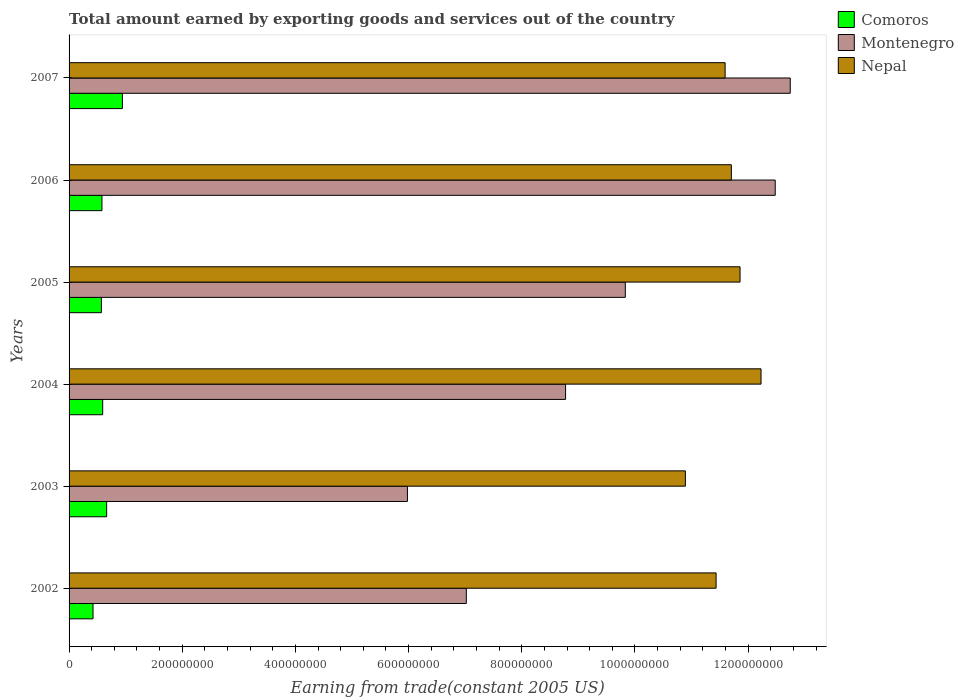How many different coloured bars are there?
Provide a short and direct response. 3. How many groups of bars are there?
Ensure brevity in your answer.  6. Are the number of bars on each tick of the Y-axis equal?
Provide a succinct answer. Yes. How many bars are there on the 6th tick from the top?
Your response must be concise. 3. What is the label of the 4th group of bars from the top?
Ensure brevity in your answer.  2004. What is the total amount earned by exporting goods and services in Comoros in 2007?
Keep it short and to the point. 9.43e+07. Across all years, what is the maximum total amount earned by exporting goods and services in Montenegro?
Keep it short and to the point. 1.27e+09. Across all years, what is the minimum total amount earned by exporting goods and services in Nepal?
Your answer should be very brief. 1.09e+09. In which year was the total amount earned by exporting goods and services in Montenegro maximum?
Your answer should be compact. 2007. In which year was the total amount earned by exporting goods and services in Montenegro minimum?
Provide a succinct answer. 2003. What is the total total amount earned by exporting goods and services in Nepal in the graph?
Your response must be concise. 6.97e+09. What is the difference between the total amount earned by exporting goods and services in Montenegro in 2002 and that in 2005?
Give a very brief answer. -2.81e+08. What is the difference between the total amount earned by exporting goods and services in Nepal in 2004 and the total amount earned by exporting goods and services in Comoros in 2006?
Make the answer very short. 1.16e+09. What is the average total amount earned by exporting goods and services in Comoros per year?
Provide a short and direct response. 6.29e+07. In the year 2002, what is the difference between the total amount earned by exporting goods and services in Montenegro and total amount earned by exporting goods and services in Nepal?
Your answer should be compact. -4.41e+08. What is the ratio of the total amount earned by exporting goods and services in Comoros in 2002 to that in 2003?
Your answer should be compact. 0.64. Is the total amount earned by exporting goods and services in Comoros in 2006 less than that in 2007?
Offer a terse response. Yes. What is the difference between the highest and the second highest total amount earned by exporting goods and services in Nepal?
Your response must be concise. 3.71e+07. What is the difference between the highest and the lowest total amount earned by exporting goods and services in Comoros?
Make the answer very short. 5.20e+07. What does the 2nd bar from the top in 2006 represents?
Offer a very short reply. Montenegro. What does the 3rd bar from the bottom in 2002 represents?
Make the answer very short. Nepal. What is the title of the graph?
Provide a short and direct response. Total amount earned by exporting goods and services out of the country. What is the label or title of the X-axis?
Your response must be concise. Earning from trade(constant 2005 US). What is the label or title of the Y-axis?
Provide a short and direct response. Years. What is the Earning from trade(constant 2005 US) of Comoros in 2002?
Provide a succinct answer. 4.23e+07. What is the Earning from trade(constant 2005 US) of Montenegro in 2002?
Your answer should be compact. 7.02e+08. What is the Earning from trade(constant 2005 US) of Nepal in 2002?
Your answer should be very brief. 1.14e+09. What is the Earning from trade(constant 2005 US) in Comoros in 2003?
Provide a succinct answer. 6.64e+07. What is the Earning from trade(constant 2005 US) in Montenegro in 2003?
Give a very brief answer. 5.98e+08. What is the Earning from trade(constant 2005 US) of Nepal in 2003?
Provide a succinct answer. 1.09e+09. What is the Earning from trade(constant 2005 US) of Comoros in 2004?
Keep it short and to the point. 5.94e+07. What is the Earning from trade(constant 2005 US) of Montenegro in 2004?
Your answer should be compact. 8.77e+08. What is the Earning from trade(constant 2005 US) in Nepal in 2004?
Provide a short and direct response. 1.22e+09. What is the Earning from trade(constant 2005 US) in Comoros in 2005?
Your answer should be compact. 5.71e+07. What is the Earning from trade(constant 2005 US) in Montenegro in 2005?
Provide a succinct answer. 9.83e+08. What is the Earning from trade(constant 2005 US) in Nepal in 2005?
Your answer should be very brief. 1.19e+09. What is the Earning from trade(constant 2005 US) of Comoros in 2006?
Offer a very short reply. 5.81e+07. What is the Earning from trade(constant 2005 US) of Montenegro in 2006?
Offer a terse response. 1.25e+09. What is the Earning from trade(constant 2005 US) of Nepal in 2006?
Make the answer very short. 1.17e+09. What is the Earning from trade(constant 2005 US) of Comoros in 2007?
Ensure brevity in your answer.  9.43e+07. What is the Earning from trade(constant 2005 US) of Montenegro in 2007?
Offer a terse response. 1.27e+09. What is the Earning from trade(constant 2005 US) of Nepal in 2007?
Offer a terse response. 1.16e+09. Across all years, what is the maximum Earning from trade(constant 2005 US) in Comoros?
Make the answer very short. 9.43e+07. Across all years, what is the maximum Earning from trade(constant 2005 US) of Montenegro?
Provide a succinct answer. 1.27e+09. Across all years, what is the maximum Earning from trade(constant 2005 US) in Nepal?
Ensure brevity in your answer.  1.22e+09. Across all years, what is the minimum Earning from trade(constant 2005 US) of Comoros?
Your response must be concise. 4.23e+07. Across all years, what is the minimum Earning from trade(constant 2005 US) of Montenegro?
Your answer should be compact. 5.98e+08. Across all years, what is the minimum Earning from trade(constant 2005 US) of Nepal?
Your answer should be very brief. 1.09e+09. What is the total Earning from trade(constant 2005 US) in Comoros in the graph?
Keep it short and to the point. 3.78e+08. What is the total Earning from trade(constant 2005 US) of Montenegro in the graph?
Offer a very short reply. 5.68e+09. What is the total Earning from trade(constant 2005 US) in Nepal in the graph?
Make the answer very short. 6.97e+09. What is the difference between the Earning from trade(constant 2005 US) in Comoros in 2002 and that in 2003?
Ensure brevity in your answer.  -2.41e+07. What is the difference between the Earning from trade(constant 2005 US) in Montenegro in 2002 and that in 2003?
Provide a short and direct response. 1.04e+08. What is the difference between the Earning from trade(constant 2005 US) of Nepal in 2002 and that in 2003?
Make the answer very short. 5.43e+07. What is the difference between the Earning from trade(constant 2005 US) of Comoros in 2002 and that in 2004?
Make the answer very short. -1.71e+07. What is the difference between the Earning from trade(constant 2005 US) of Montenegro in 2002 and that in 2004?
Your answer should be compact. -1.75e+08. What is the difference between the Earning from trade(constant 2005 US) of Nepal in 2002 and that in 2004?
Provide a succinct answer. -7.94e+07. What is the difference between the Earning from trade(constant 2005 US) in Comoros in 2002 and that in 2005?
Give a very brief answer. -1.48e+07. What is the difference between the Earning from trade(constant 2005 US) of Montenegro in 2002 and that in 2005?
Your answer should be compact. -2.81e+08. What is the difference between the Earning from trade(constant 2005 US) in Nepal in 2002 and that in 2005?
Provide a succinct answer. -4.23e+07. What is the difference between the Earning from trade(constant 2005 US) of Comoros in 2002 and that in 2006?
Your answer should be very brief. -1.58e+07. What is the difference between the Earning from trade(constant 2005 US) in Montenegro in 2002 and that in 2006?
Give a very brief answer. -5.46e+08. What is the difference between the Earning from trade(constant 2005 US) of Nepal in 2002 and that in 2006?
Provide a succinct answer. -2.70e+07. What is the difference between the Earning from trade(constant 2005 US) of Comoros in 2002 and that in 2007?
Ensure brevity in your answer.  -5.20e+07. What is the difference between the Earning from trade(constant 2005 US) in Montenegro in 2002 and that in 2007?
Your answer should be compact. -5.72e+08. What is the difference between the Earning from trade(constant 2005 US) in Nepal in 2002 and that in 2007?
Your answer should be compact. -1.59e+07. What is the difference between the Earning from trade(constant 2005 US) in Comoros in 2003 and that in 2004?
Your answer should be compact. 6.98e+06. What is the difference between the Earning from trade(constant 2005 US) in Montenegro in 2003 and that in 2004?
Keep it short and to the point. -2.79e+08. What is the difference between the Earning from trade(constant 2005 US) in Nepal in 2003 and that in 2004?
Offer a terse response. -1.34e+08. What is the difference between the Earning from trade(constant 2005 US) in Comoros in 2003 and that in 2005?
Keep it short and to the point. 9.30e+06. What is the difference between the Earning from trade(constant 2005 US) in Montenegro in 2003 and that in 2005?
Provide a short and direct response. -3.85e+08. What is the difference between the Earning from trade(constant 2005 US) in Nepal in 2003 and that in 2005?
Your response must be concise. -9.66e+07. What is the difference between the Earning from trade(constant 2005 US) of Comoros in 2003 and that in 2006?
Give a very brief answer. 8.30e+06. What is the difference between the Earning from trade(constant 2005 US) of Montenegro in 2003 and that in 2006?
Your response must be concise. -6.50e+08. What is the difference between the Earning from trade(constant 2005 US) of Nepal in 2003 and that in 2006?
Provide a succinct answer. -8.13e+07. What is the difference between the Earning from trade(constant 2005 US) of Comoros in 2003 and that in 2007?
Offer a very short reply. -2.79e+07. What is the difference between the Earning from trade(constant 2005 US) in Montenegro in 2003 and that in 2007?
Provide a short and direct response. -6.76e+08. What is the difference between the Earning from trade(constant 2005 US) of Nepal in 2003 and that in 2007?
Provide a short and direct response. -7.02e+07. What is the difference between the Earning from trade(constant 2005 US) in Comoros in 2004 and that in 2005?
Offer a terse response. 2.31e+06. What is the difference between the Earning from trade(constant 2005 US) of Montenegro in 2004 and that in 2005?
Provide a succinct answer. -1.06e+08. What is the difference between the Earning from trade(constant 2005 US) of Nepal in 2004 and that in 2005?
Make the answer very short. 3.71e+07. What is the difference between the Earning from trade(constant 2005 US) of Comoros in 2004 and that in 2006?
Your answer should be very brief. 1.32e+06. What is the difference between the Earning from trade(constant 2005 US) of Montenegro in 2004 and that in 2006?
Your answer should be very brief. -3.70e+08. What is the difference between the Earning from trade(constant 2005 US) in Nepal in 2004 and that in 2006?
Make the answer very short. 5.24e+07. What is the difference between the Earning from trade(constant 2005 US) in Comoros in 2004 and that in 2007?
Provide a short and direct response. -3.48e+07. What is the difference between the Earning from trade(constant 2005 US) in Montenegro in 2004 and that in 2007?
Provide a succinct answer. -3.97e+08. What is the difference between the Earning from trade(constant 2005 US) in Nepal in 2004 and that in 2007?
Offer a terse response. 6.35e+07. What is the difference between the Earning from trade(constant 2005 US) of Comoros in 2005 and that in 2006?
Offer a very short reply. -9.93e+05. What is the difference between the Earning from trade(constant 2005 US) in Montenegro in 2005 and that in 2006?
Your response must be concise. -2.65e+08. What is the difference between the Earning from trade(constant 2005 US) in Nepal in 2005 and that in 2006?
Give a very brief answer. 1.53e+07. What is the difference between the Earning from trade(constant 2005 US) in Comoros in 2005 and that in 2007?
Your response must be concise. -3.72e+07. What is the difference between the Earning from trade(constant 2005 US) in Montenegro in 2005 and that in 2007?
Provide a succinct answer. -2.91e+08. What is the difference between the Earning from trade(constant 2005 US) of Nepal in 2005 and that in 2007?
Offer a very short reply. 2.64e+07. What is the difference between the Earning from trade(constant 2005 US) in Comoros in 2006 and that in 2007?
Your answer should be compact. -3.62e+07. What is the difference between the Earning from trade(constant 2005 US) in Montenegro in 2006 and that in 2007?
Make the answer very short. -2.65e+07. What is the difference between the Earning from trade(constant 2005 US) in Nepal in 2006 and that in 2007?
Keep it short and to the point. 1.11e+07. What is the difference between the Earning from trade(constant 2005 US) of Comoros in 2002 and the Earning from trade(constant 2005 US) of Montenegro in 2003?
Offer a very short reply. -5.56e+08. What is the difference between the Earning from trade(constant 2005 US) in Comoros in 2002 and the Earning from trade(constant 2005 US) in Nepal in 2003?
Give a very brief answer. -1.05e+09. What is the difference between the Earning from trade(constant 2005 US) in Montenegro in 2002 and the Earning from trade(constant 2005 US) in Nepal in 2003?
Offer a terse response. -3.87e+08. What is the difference between the Earning from trade(constant 2005 US) in Comoros in 2002 and the Earning from trade(constant 2005 US) in Montenegro in 2004?
Provide a short and direct response. -8.35e+08. What is the difference between the Earning from trade(constant 2005 US) of Comoros in 2002 and the Earning from trade(constant 2005 US) of Nepal in 2004?
Offer a very short reply. -1.18e+09. What is the difference between the Earning from trade(constant 2005 US) in Montenegro in 2002 and the Earning from trade(constant 2005 US) in Nepal in 2004?
Offer a terse response. -5.21e+08. What is the difference between the Earning from trade(constant 2005 US) of Comoros in 2002 and the Earning from trade(constant 2005 US) of Montenegro in 2005?
Make the answer very short. -9.41e+08. What is the difference between the Earning from trade(constant 2005 US) in Comoros in 2002 and the Earning from trade(constant 2005 US) in Nepal in 2005?
Offer a very short reply. -1.14e+09. What is the difference between the Earning from trade(constant 2005 US) in Montenegro in 2002 and the Earning from trade(constant 2005 US) in Nepal in 2005?
Your response must be concise. -4.84e+08. What is the difference between the Earning from trade(constant 2005 US) of Comoros in 2002 and the Earning from trade(constant 2005 US) of Montenegro in 2006?
Your answer should be compact. -1.21e+09. What is the difference between the Earning from trade(constant 2005 US) in Comoros in 2002 and the Earning from trade(constant 2005 US) in Nepal in 2006?
Offer a very short reply. -1.13e+09. What is the difference between the Earning from trade(constant 2005 US) in Montenegro in 2002 and the Earning from trade(constant 2005 US) in Nepal in 2006?
Provide a succinct answer. -4.68e+08. What is the difference between the Earning from trade(constant 2005 US) of Comoros in 2002 and the Earning from trade(constant 2005 US) of Montenegro in 2007?
Offer a very short reply. -1.23e+09. What is the difference between the Earning from trade(constant 2005 US) in Comoros in 2002 and the Earning from trade(constant 2005 US) in Nepal in 2007?
Your answer should be very brief. -1.12e+09. What is the difference between the Earning from trade(constant 2005 US) of Montenegro in 2002 and the Earning from trade(constant 2005 US) of Nepal in 2007?
Your answer should be compact. -4.57e+08. What is the difference between the Earning from trade(constant 2005 US) in Comoros in 2003 and the Earning from trade(constant 2005 US) in Montenegro in 2004?
Provide a short and direct response. -8.11e+08. What is the difference between the Earning from trade(constant 2005 US) of Comoros in 2003 and the Earning from trade(constant 2005 US) of Nepal in 2004?
Your answer should be compact. -1.16e+09. What is the difference between the Earning from trade(constant 2005 US) in Montenegro in 2003 and the Earning from trade(constant 2005 US) in Nepal in 2004?
Your answer should be very brief. -6.25e+08. What is the difference between the Earning from trade(constant 2005 US) of Comoros in 2003 and the Earning from trade(constant 2005 US) of Montenegro in 2005?
Provide a short and direct response. -9.17e+08. What is the difference between the Earning from trade(constant 2005 US) of Comoros in 2003 and the Earning from trade(constant 2005 US) of Nepal in 2005?
Make the answer very short. -1.12e+09. What is the difference between the Earning from trade(constant 2005 US) of Montenegro in 2003 and the Earning from trade(constant 2005 US) of Nepal in 2005?
Your response must be concise. -5.88e+08. What is the difference between the Earning from trade(constant 2005 US) of Comoros in 2003 and the Earning from trade(constant 2005 US) of Montenegro in 2006?
Offer a terse response. -1.18e+09. What is the difference between the Earning from trade(constant 2005 US) in Comoros in 2003 and the Earning from trade(constant 2005 US) in Nepal in 2006?
Make the answer very short. -1.10e+09. What is the difference between the Earning from trade(constant 2005 US) of Montenegro in 2003 and the Earning from trade(constant 2005 US) of Nepal in 2006?
Give a very brief answer. -5.72e+08. What is the difference between the Earning from trade(constant 2005 US) in Comoros in 2003 and the Earning from trade(constant 2005 US) in Montenegro in 2007?
Give a very brief answer. -1.21e+09. What is the difference between the Earning from trade(constant 2005 US) in Comoros in 2003 and the Earning from trade(constant 2005 US) in Nepal in 2007?
Give a very brief answer. -1.09e+09. What is the difference between the Earning from trade(constant 2005 US) of Montenegro in 2003 and the Earning from trade(constant 2005 US) of Nepal in 2007?
Keep it short and to the point. -5.61e+08. What is the difference between the Earning from trade(constant 2005 US) in Comoros in 2004 and the Earning from trade(constant 2005 US) in Montenegro in 2005?
Give a very brief answer. -9.24e+08. What is the difference between the Earning from trade(constant 2005 US) of Comoros in 2004 and the Earning from trade(constant 2005 US) of Nepal in 2005?
Provide a succinct answer. -1.13e+09. What is the difference between the Earning from trade(constant 2005 US) in Montenegro in 2004 and the Earning from trade(constant 2005 US) in Nepal in 2005?
Provide a succinct answer. -3.08e+08. What is the difference between the Earning from trade(constant 2005 US) of Comoros in 2004 and the Earning from trade(constant 2005 US) of Montenegro in 2006?
Ensure brevity in your answer.  -1.19e+09. What is the difference between the Earning from trade(constant 2005 US) in Comoros in 2004 and the Earning from trade(constant 2005 US) in Nepal in 2006?
Offer a very short reply. -1.11e+09. What is the difference between the Earning from trade(constant 2005 US) in Montenegro in 2004 and the Earning from trade(constant 2005 US) in Nepal in 2006?
Your answer should be very brief. -2.93e+08. What is the difference between the Earning from trade(constant 2005 US) of Comoros in 2004 and the Earning from trade(constant 2005 US) of Montenegro in 2007?
Your response must be concise. -1.21e+09. What is the difference between the Earning from trade(constant 2005 US) in Comoros in 2004 and the Earning from trade(constant 2005 US) in Nepal in 2007?
Provide a short and direct response. -1.10e+09. What is the difference between the Earning from trade(constant 2005 US) of Montenegro in 2004 and the Earning from trade(constant 2005 US) of Nepal in 2007?
Offer a terse response. -2.82e+08. What is the difference between the Earning from trade(constant 2005 US) in Comoros in 2005 and the Earning from trade(constant 2005 US) in Montenegro in 2006?
Your answer should be compact. -1.19e+09. What is the difference between the Earning from trade(constant 2005 US) of Comoros in 2005 and the Earning from trade(constant 2005 US) of Nepal in 2006?
Make the answer very short. -1.11e+09. What is the difference between the Earning from trade(constant 2005 US) in Montenegro in 2005 and the Earning from trade(constant 2005 US) in Nepal in 2006?
Keep it short and to the point. -1.87e+08. What is the difference between the Earning from trade(constant 2005 US) in Comoros in 2005 and the Earning from trade(constant 2005 US) in Montenegro in 2007?
Offer a very short reply. -1.22e+09. What is the difference between the Earning from trade(constant 2005 US) in Comoros in 2005 and the Earning from trade(constant 2005 US) in Nepal in 2007?
Make the answer very short. -1.10e+09. What is the difference between the Earning from trade(constant 2005 US) in Montenegro in 2005 and the Earning from trade(constant 2005 US) in Nepal in 2007?
Give a very brief answer. -1.76e+08. What is the difference between the Earning from trade(constant 2005 US) of Comoros in 2006 and the Earning from trade(constant 2005 US) of Montenegro in 2007?
Your response must be concise. -1.22e+09. What is the difference between the Earning from trade(constant 2005 US) of Comoros in 2006 and the Earning from trade(constant 2005 US) of Nepal in 2007?
Provide a short and direct response. -1.10e+09. What is the difference between the Earning from trade(constant 2005 US) in Montenegro in 2006 and the Earning from trade(constant 2005 US) in Nepal in 2007?
Provide a succinct answer. 8.86e+07. What is the average Earning from trade(constant 2005 US) in Comoros per year?
Offer a terse response. 6.29e+07. What is the average Earning from trade(constant 2005 US) in Montenegro per year?
Your answer should be compact. 9.47e+08. What is the average Earning from trade(constant 2005 US) of Nepal per year?
Give a very brief answer. 1.16e+09. In the year 2002, what is the difference between the Earning from trade(constant 2005 US) of Comoros and Earning from trade(constant 2005 US) of Montenegro?
Make the answer very short. -6.60e+08. In the year 2002, what is the difference between the Earning from trade(constant 2005 US) in Comoros and Earning from trade(constant 2005 US) in Nepal?
Offer a terse response. -1.10e+09. In the year 2002, what is the difference between the Earning from trade(constant 2005 US) in Montenegro and Earning from trade(constant 2005 US) in Nepal?
Your response must be concise. -4.41e+08. In the year 2003, what is the difference between the Earning from trade(constant 2005 US) of Comoros and Earning from trade(constant 2005 US) of Montenegro?
Provide a succinct answer. -5.32e+08. In the year 2003, what is the difference between the Earning from trade(constant 2005 US) of Comoros and Earning from trade(constant 2005 US) of Nepal?
Your answer should be very brief. -1.02e+09. In the year 2003, what is the difference between the Earning from trade(constant 2005 US) in Montenegro and Earning from trade(constant 2005 US) in Nepal?
Ensure brevity in your answer.  -4.91e+08. In the year 2004, what is the difference between the Earning from trade(constant 2005 US) in Comoros and Earning from trade(constant 2005 US) in Montenegro?
Your answer should be very brief. -8.18e+08. In the year 2004, what is the difference between the Earning from trade(constant 2005 US) of Comoros and Earning from trade(constant 2005 US) of Nepal?
Offer a very short reply. -1.16e+09. In the year 2004, what is the difference between the Earning from trade(constant 2005 US) in Montenegro and Earning from trade(constant 2005 US) in Nepal?
Keep it short and to the point. -3.45e+08. In the year 2005, what is the difference between the Earning from trade(constant 2005 US) in Comoros and Earning from trade(constant 2005 US) in Montenegro?
Give a very brief answer. -9.26e+08. In the year 2005, what is the difference between the Earning from trade(constant 2005 US) of Comoros and Earning from trade(constant 2005 US) of Nepal?
Provide a short and direct response. -1.13e+09. In the year 2005, what is the difference between the Earning from trade(constant 2005 US) of Montenegro and Earning from trade(constant 2005 US) of Nepal?
Your answer should be very brief. -2.03e+08. In the year 2006, what is the difference between the Earning from trade(constant 2005 US) in Comoros and Earning from trade(constant 2005 US) in Montenegro?
Your answer should be very brief. -1.19e+09. In the year 2006, what is the difference between the Earning from trade(constant 2005 US) in Comoros and Earning from trade(constant 2005 US) in Nepal?
Provide a short and direct response. -1.11e+09. In the year 2006, what is the difference between the Earning from trade(constant 2005 US) of Montenegro and Earning from trade(constant 2005 US) of Nepal?
Keep it short and to the point. 7.75e+07. In the year 2007, what is the difference between the Earning from trade(constant 2005 US) of Comoros and Earning from trade(constant 2005 US) of Montenegro?
Your answer should be very brief. -1.18e+09. In the year 2007, what is the difference between the Earning from trade(constant 2005 US) in Comoros and Earning from trade(constant 2005 US) in Nepal?
Offer a terse response. -1.07e+09. In the year 2007, what is the difference between the Earning from trade(constant 2005 US) of Montenegro and Earning from trade(constant 2005 US) of Nepal?
Your answer should be compact. 1.15e+08. What is the ratio of the Earning from trade(constant 2005 US) in Comoros in 2002 to that in 2003?
Ensure brevity in your answer.  0.64. What is the ratio of the Earning from trade(constant 2005 US) in Montenegro in 2002 to that in 2003?
Keep it short and to the point. 1.17. What is the ratio of the Earning from trade(constant 2005 US) of Nepal in 2002 to that in 2003?
Your answer should be compact. 1.05. What is the ratio of the Earning from trade(constant 2005 US) in Comoros in 2002 to that in 2004?
Give a very brief answer. 0.71. What is the ratio of the Earning from trade(constant 2005 US) of Montenegro in 2002 to that in 2004?
Your response must be concise. 0.8. What is the ratio of the Earning from trade(constant 2005 US) in Nepal in 2002 to that in 2004?
Your answer should be very brief. 0.94. What is the ratio of the Earning from trade(constant 2005 US) of Comoros in 2002 to that in 2005?
Your answer should be very brief. 0.74. What is the ratio of the Earning from trade(constant 2005 US) in Montenegro in 2002 to that in 2005?
Your response must be concise. 0.71. What is the ratio of the Earning from trade(constant 2005 US) of Nepal in 2002 to that in 2005?
Your response must be concise. 0.96. What is the ratio of the Earning from trade(constant 2005 US) of Comoros in 2002 to that in 2006?
Keep it short and to the point. 0.73. What is the ratio of the Earning from trade(constant 2005 US) in Montenegro in 2002 to that in 2006?
Your answer should be very brief. 0.56. What is the ratio of the Earning from trade(constant 2005 US) in Nepal in 2002 to that in 2006?
Offer a very short reply. 0.98. What is the ratio of the Earning from trade(constant 2005 US) of Comoros in 2002 to that in 2007?
Provide a succinct answer. 0.45. What is the ratio of the Earning from trade(constant 2005 US) of Montenegro in 2002 to that in 2007?
Make the answer very short. 0.55. What is the ratio of the Earning from trade(constant 2005 US) of Nepal in 2002 to that in 2007?
Your answer should be very brief. 0.99. What is the ratio of the Earning from trade(constant 2005 US) of Comoros in 2003 to that in 2004?
Keep it short and to the point. 1.12. What is the ratio of the Earning from trade(constant 2005 US) of Montenegro in 2003 to that in 2004?
Make the answer very short. 0.68. What is the ratio of the Earning from trade(constant 2005 US) of Nepal in 2003 to that in 2004?
Your answer should be very brief. 0.89. What is the ratio of the Earning from trade(constant 2005 US) of Comoros in 2003 to that in 2005?
Your answer should be compact. 1.16. What is the ratio of the Earning from trade(constant 2005 US) in Montenegro in 2003 to that in 2005?
Provide a succinct answer. 0.61. What is the ratio of the Earning from trade(constant 2005 US) in Nepal in 2003 to that in 2005?
Ensure brevity in your answer.  0.92. What is the ratio of the Earning from trade(constant 2005 US) in Comoros in 2003 to that in 2006?
Offer a terse response. 1.14. What is the ratio of the Earning from trade(constant 2005 US) in Montenegro in 2003 to that in 2006?
Provide a short and direct response. 0.48. What is the ratio of the Earning from trade(constant 2005 US) of Nepal in 2003 to that in 2006?
Your answer should be compact. 0.93. What is the ratio of the Earning from trade(constant 2005 US) in Comoros in 2003 to that in 2007?
Keep it short and to the point. 0.7. What is the ratio of the Earning from trade(constant 2005 US) of Montenegro in 2003 to that in 2007?
Your answer should be very brief. 0.47. What is the ratio of the Earning from trade(constant 2005 US) in Nepal in 2003 to that in 2007?
Ensure brevity in your answer.  0.94. What is the ratio of the Earning from trade(constant 2005 US) in Comoros in 2004 to that in 2005?
Give a very brief answer. 1.04. What is the ratio of the Earning from trade(constant 2005 US) in Montenegro in 2004 to that in 2005?
Offer a very short reply. 0.89. What is the ratio of the Earning from trade(constant 2005 US) of Nepal in 2004 to that in 2005?
Offer a terse response. 1.03. What is the ratio of the Earning from trade(constant 2005 US) in Comoros in 2004 to that in 2006?
Your response must be concise. 1.02. What is the ratio of the Earning from trade(constant 2005 US) in Montenegro in 2004 to that in 2006?
Ensure brevity in your answer.  0.7. What is the ratio of the Earning from trade(constant 2005 US) in Nepal in 2004 to that in 2006?
Offer a very short reply. 1.04. What is the ratio of the Earning from trade(constant 2005 US) in Comoros in 2004 to that in 2007?
Offer a very short reply. 0.63. What is the ratio of the Earning from trade(constant 2005 US) of Montenegro in 2004 to that in 2007?
Your answer should be compact. 0.69. What is the ratio of the Earning from trade(constant 2005 US) of Nepal in 2004 to that in 2007?
Offer a terse response. 1.05. What is the ratio of the Earning from trade(constant 2005 US) of Comoros in 2005 to that in 2006?
Provide a succinct answer. 0.98. What is the ratio of the Earning from trade(constant 2005 US) in Montenegro in 2005 to that in 2006?
Give a very brief answer. 0.79. What is the ratio of the Earning from trade(constant 2005 US) in Nepal in 2005 to that in 2006?
Provide a short and direct response. 1.01. What is the ratio of the Earning from trade(constant 2005 US) of Comoros in 2005 to that in 2007?
Ensure brevity in your answer.  0.61. What is the ratio of the Earning from trade(constant 2005 US) in Montenegro in 2005 to that in 2007?
Keep it short and to the point. 0.77. What is the ratio of the Earning from trade(constant 2005 US) of Nepal in 2005 to that in 2007?
Offer a terse response. 1.02. What is the ratio of the Earning from trade(constant 2005 US) in Comoros in 2006 to that in 2007?
Offer a terse response. 0.62. What is the ratio of the Earning from trade(constant 2005 US) in Montenegro in 2006 to that in 2007?
Provide a short and direct response. 0.98. What is the ratio of the Earning from trade(constant 2005 US) in Nepal in 2006 to that in 2007?
Make the answer very short. 1.01. What is the difference between the highest and the second highest Earning from trade(constant 2005 US) in Comoros?
Ensure brevity in your answer.  2.79e+07. What is the difference between the highest and the second highest Earning from trade(constant 2005 US) of Montenegro?
Provide a short and direct response. 2.65e+07. What is the difference between the highest and the second highest Earning from trade(constant 2005 US) in Nepal?
Offer a terse response. 3.71e+07. What is the difference between the highest and the lowest Earning from trade(constant 2005 US) in Comoros?
Your answer should be very brief. 5.20e+07. What is the difference between the highest and the lowest Earning from trade(constant 2005 US) in Montenegro?
Offer a terse response. 6.76e+08. What is the difference between the highest and the lowest Earning from trade(constant 2005 US) in Nepal?
Keep it short and to the point. 1.34e+08. 